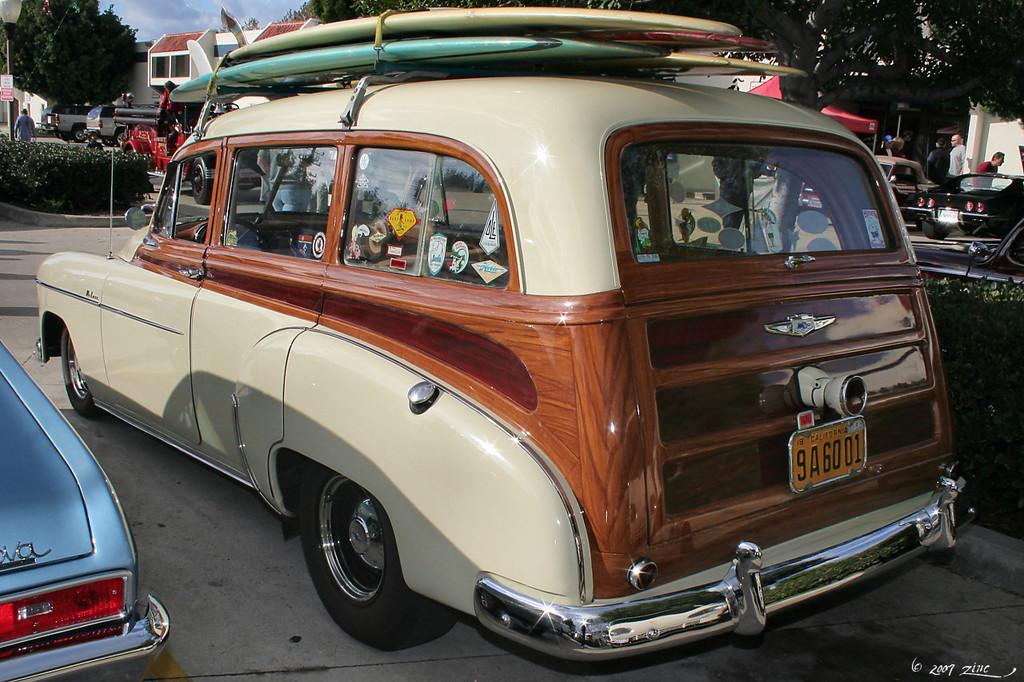What types of objects are present in the image? There are vehicles and a board in the image. Are there any living beings in the image? Yes, there are people in the image. What can be seen in the background of the image? There are trees, buildings, and the sky visible in the background of the image. How many cows are grazing near the dock in the image? There are no cows or docks present in the image. What is the position of the sun in the image? The provided facts do not mention the position of the sun in the image. 